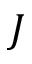<formula> <loc_0><loc_0><loc_500><loc_500>J</formula> 